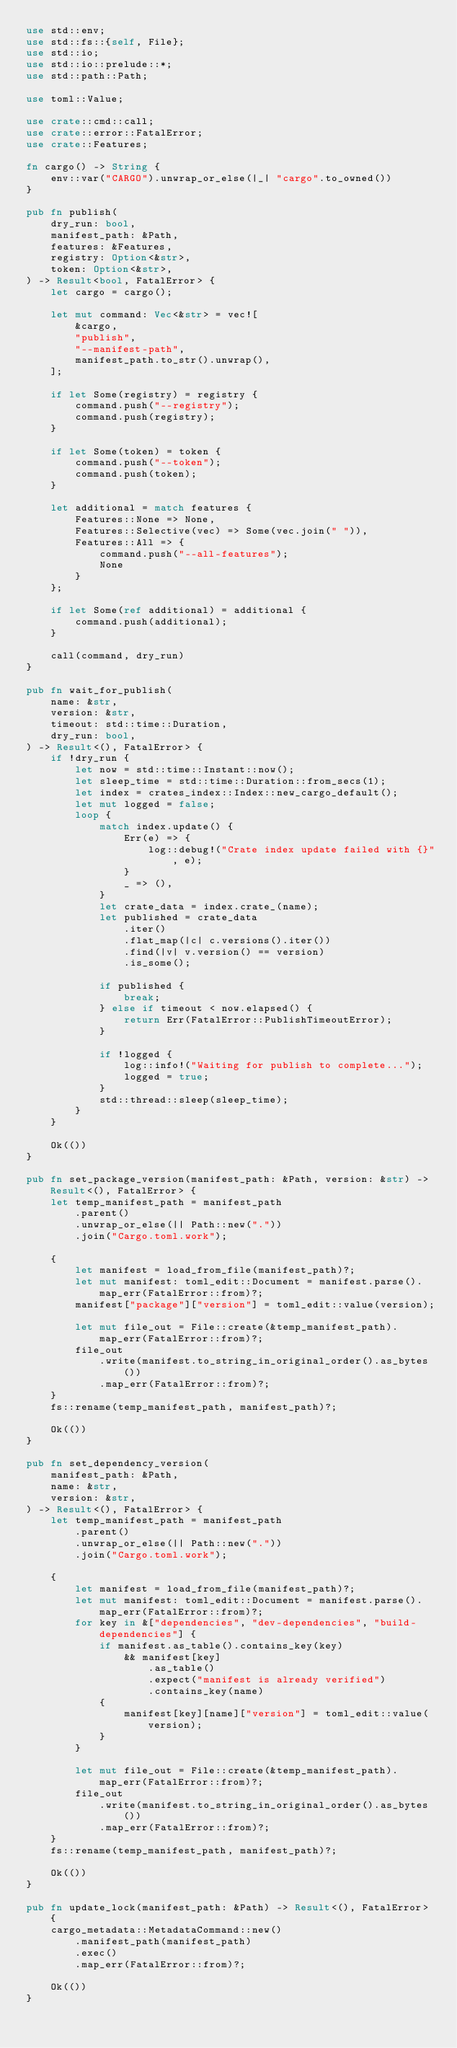Convert code to text. <code><loc_0><loc_0><loc_500><loc_500><_Rust_>use std::env;
use std::fs::{self, File};
use std::io;
use std::io::prelude::*;
use std::path::Path;

use toml::Value;

use crate::cmd::call;
use crate::error::FatalError;
use crate::Features;

fn cargo() -> String {
    env::var("CARGO").unwrap_or_else(|_| "cargo".to_owned())
}

pub fn publish(
    dry_run: bool,
    manifest_path: &Path,
    features: &Features,
    registry: Option<&str>,
    token: Option<&str>,
) -> Result<bool, FatalError> {
    let cargo = cargo();

    let mut command: Vec<&str> = vec![
        &cargo,
        "publish",
        "--manifest-path",
        manifest_path.to_str().unwrap(),
    ];

    if let Some(registry) = registry {
        command.push("--registry");
        command.push(registry);
    }

    if let Some(token) = token {
        command.push("--token");
        command.push(token);
    }

    let additional = match features {
        Features::None => None,
        Features::Selective(vec) => Some(vec.join(" ")),
        Features::All => {
            command.push("--all-features");
            None
        }
    };

    if let Some(ref additional) = additional {
        command.push(additional);
    }

    call(command, dry_run)
}

pub fn wait_for_publish(
    name: &str,
    version: &str,
    timeout: std::time::Duration,
    dry_run: bool,
) -> Result<(), FatalError> {
    if !dry_run {
        let now = std::time::Instant::now();
        let sleep_time = std::time::Duration::from_secs(1);
        let index = crates_index::Index::new_cargo_default();
        let mut logged = false;
        loop {
            match index.update() {
                Err(e) => {
                    log::debug!("Crate index update failed with {}", e);
                }
                _ => (),
            }
            let crate_data = index.crate_(name);
            let published = crate_data
                .iter()
                .flat_map(|c| c.versions().iter())
                .find(|v| v.version() == version)
                .is_some();

            if published {
                break;
            } else if timeout < now.elapsed() {
                return Err(FatalError::PublishTimeoutError);
            }

            if !logged {
                log::info!("Waiting for publish to complete...");
                logged = true;
            }
            std::thread::sleep(sleep_time);
        }
    }

    Ok(())
}

pub fn set_package_version(manifest_path: &Path, version: &str) -> Result<(), FatalError> {
    let temp_manifest_path = manifest_path
        .parent()
        .unwrap_or_else(|| Path::new("."))
        .join("Cargo.toml.work");

    {
        let manifest = load_from_file(manifest_path)?;
        let mut manifest: toml_edit::Document = manifest.parse().map_err(FatalError::from)?;
        manifest["package"]["version"] = toml_edit::value(version);

        let mut file_out = File::create(&temp_manifest_path).map_err(FatalError::from)?;
        file_out
            .write(manifest.to_string_in_original_order().as_bytes())
            .map_err(FatalError::from)?;
    }
    fs::rename(temp_manifest_path, manifest_path)?;

    Ok(())
}

pub fn set_dependency_version(
    manifest_path: &Path,
    name: &str,
    version: &str,
) -> Result<(), FatalError> {
    let temp_manifest_path = manifest_path
        .parent()
        .unwrap_or_else(|| Path::new("."))
        .join("Cargo.toml.work");

    {
        let manifest = load_from_file(manifest_path)?;
        let mut manifest: toml_edit::Document = manifest.parse().map_err(FatalError::from)?;
        for key in &["dependencies", "dev-dependencies", "build-dependencies"] {
            if manifest.as_table().contains_key(key)
                && manifest[key]
                    .as_table()
                    .expect("manifest is already verified")
                    .contains_key(name)
            {
                manifest[key][name]["version"] = toml_edit::value(version);
            }
        }

        let mut file_out = File::create(&temp_manifest_path).map_err(FatalError::from)?;
        file_out
            .write(manifest.to_string_in_original_order().as_bytes())
            .map_err(FatalError::from)?;
    }
    fs::rename(temp_manifest_path, manifest_path)?;

    Ok(())
}

pub fn update_lock(manifest_path: &Path) -> Result<(), FatalError> {
    cargo_metadata::MetadataCommand::new()
        .manifest_path(manifest_path)
        .exec()
        .map_err(FatalError::from)?;

    Ok(())
}
</code> 